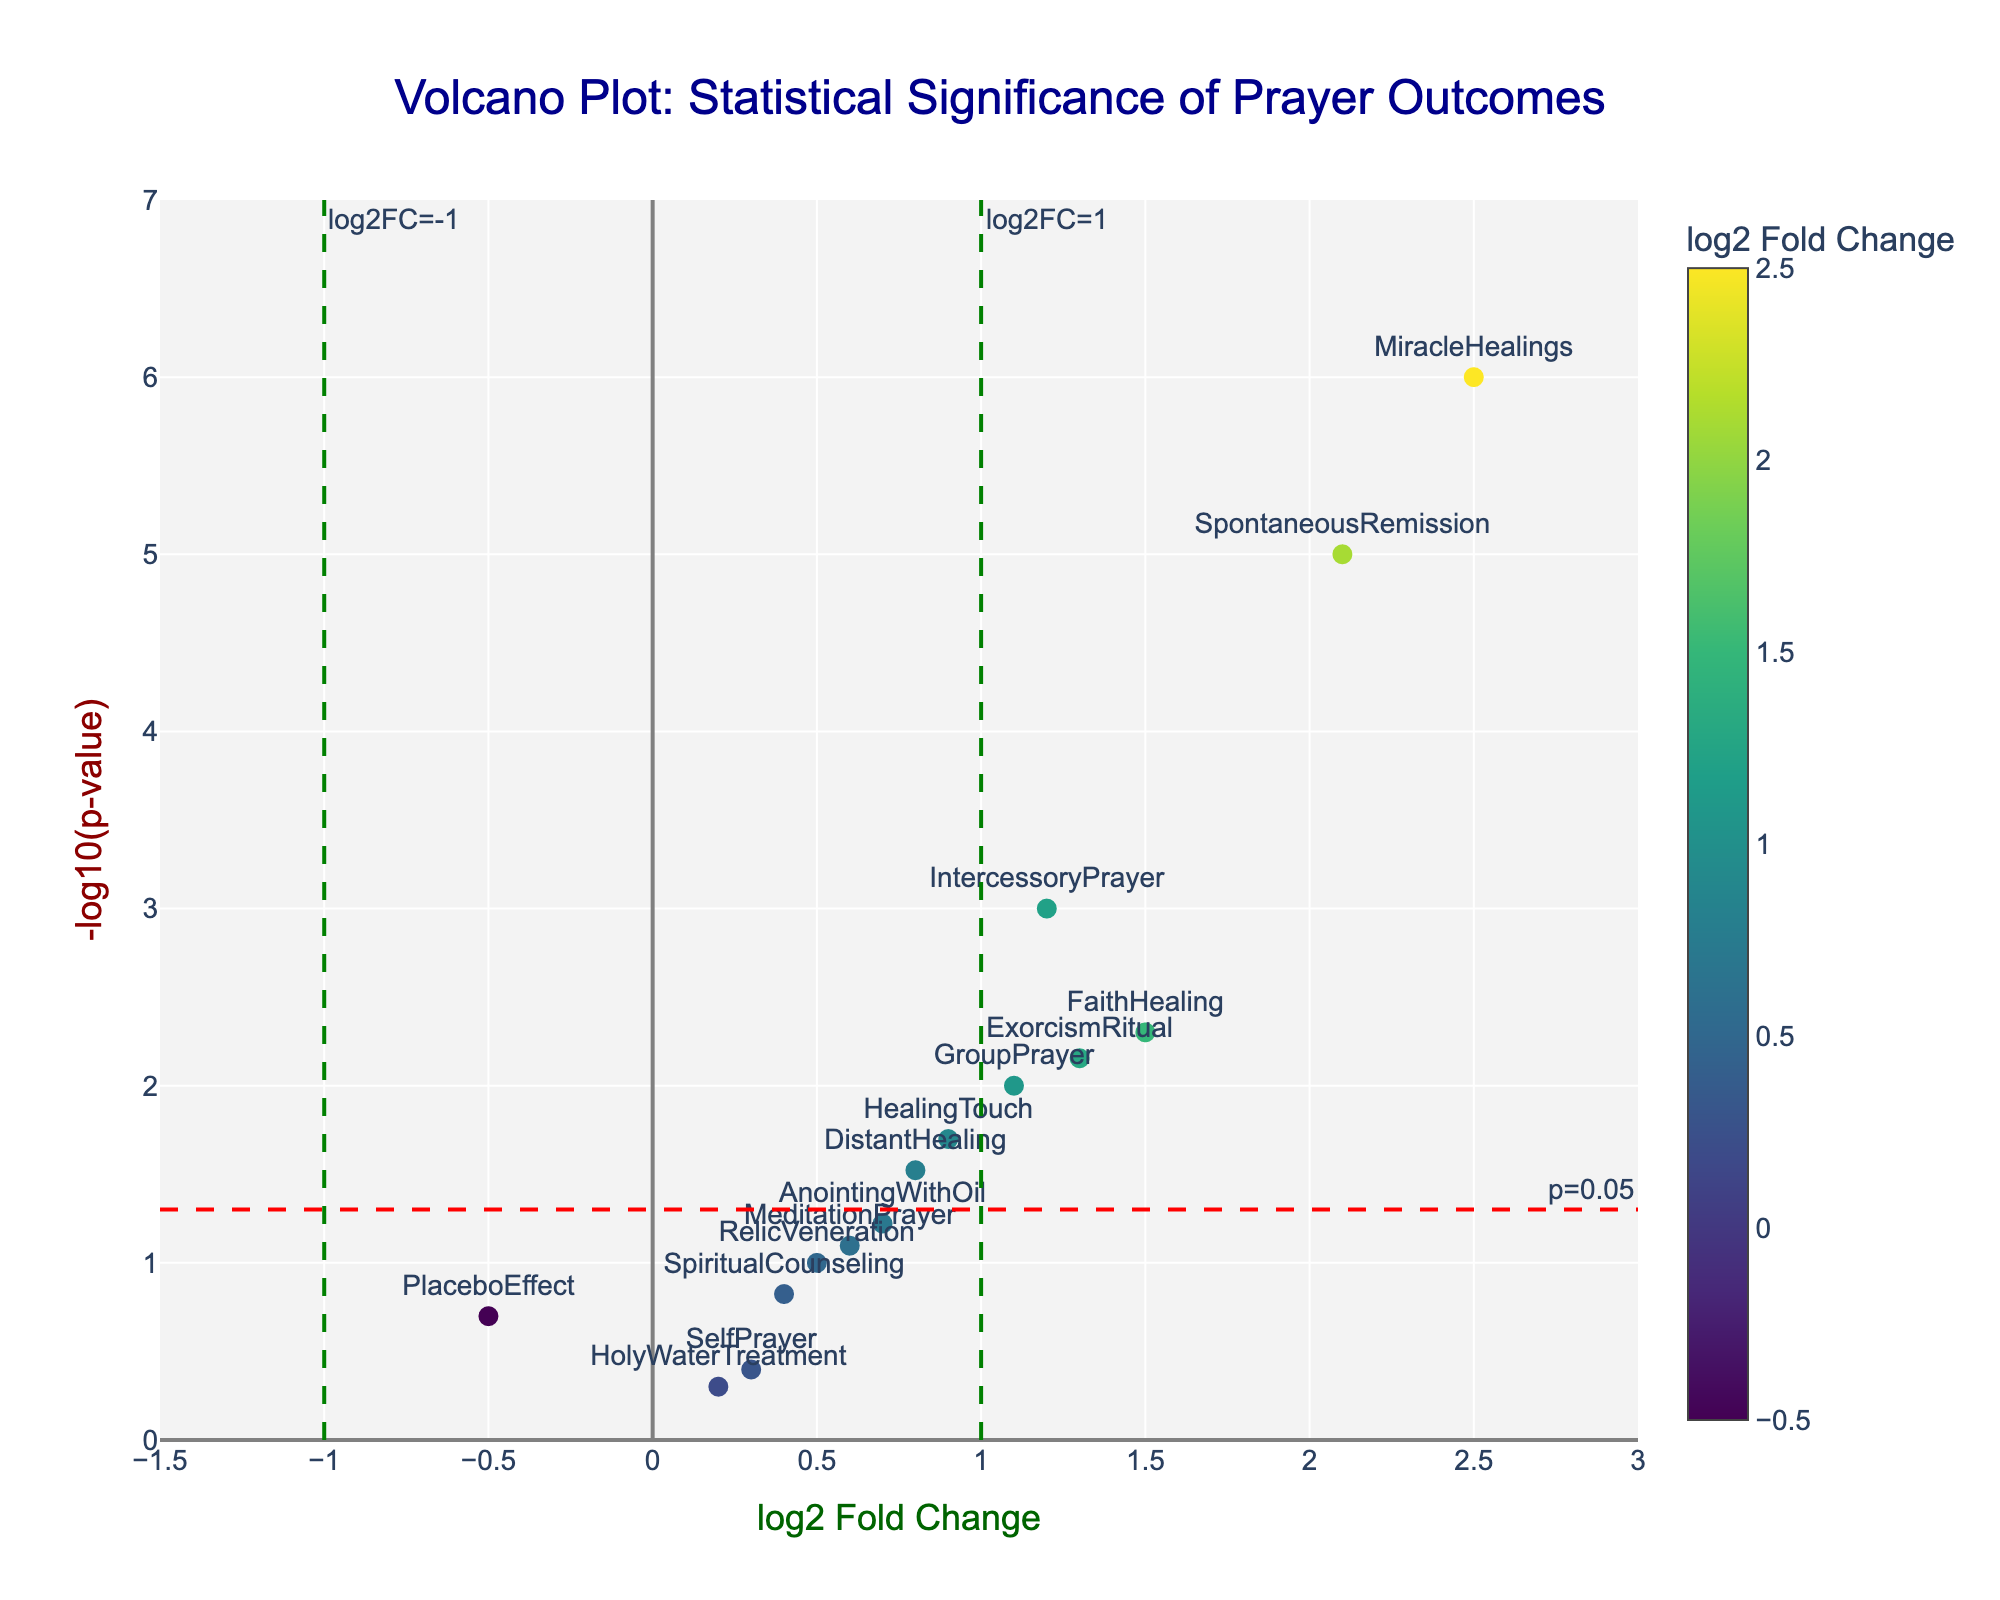What is the title of the figure? The title is prominently displayed at the top of the plot and reads "Volcano Plot: Statistical Significance of Prayer Outcomes".
Answer: Volcano Plot: Statistical Significance of Prayer Outcomes Which axis represents the log2 Fold Change? The x-axis title reads "log2 Fold Change", indicating that the x-axis represents the log2 Fold Change.
Answer: x-axis Which data point has the highest log2 Fold Change? By observing the x-axis values, the data point labeled "MiracleHealings" is farthest to the right, thus having the highest log2 Fold Change.
Answer: MiracleHealings What is the p-value threshold indicated by a dashed red line? The dashed red line, labeled as "p=0.05," sets the p-value threshold, which corresponds to a -log10(p-value) of approximately 1.3.
Answer: 0.05 How many points have a log2 Fold Change greater than 1? Identifying points to the right of the vertical green line labeled "log2FC=1", we count: IntercessoryPrayer, SpontaneousRemission, FaithHealing, GroupPrayer, ExorcismRitual, and MiracleHealings—totaling six points.
Answer: 6 Which data point has the lowest p-value? The lowest p-value corresponds to the highest -log10(p-value) on the y-axis. MiracleHealings is the data point positioned highest on the y-axis, indicating it has the lowest p-value.
Answer: MiracleHealings Between “IntercessoryPrayer” and “GroupPrayer,” which has a higher -log10(p-value)? Comparing the y-axis positions of IntercessoryPrayer and GroupPrayer, IntercessoryPrayer is placed higher, suggesting it has a higher -log10(p-value).
Answer: IntercessoryPrayer Which points are below the significance threshold and to the left of the log2FC=-1 line? There are no points to the left of the log2FC=-1 line, as all lie to the right of it in the given plot.
Answer: None What is the -log10(p-value) of “FaithHealing”? To find the exact value for FaithHealing on the y-axis: the y-coordinate of the point corresponding to FaithHealing, represented by its placement, gives a -log10(p-value) of approximately 2.3.
Answer: ~2.3 What does the color gradient in the plot represent? The color gradient in the plot, shown by the color bar beside the plot, represents the log2 Fold Change of the data points.
Answer: log2 Fold Change 